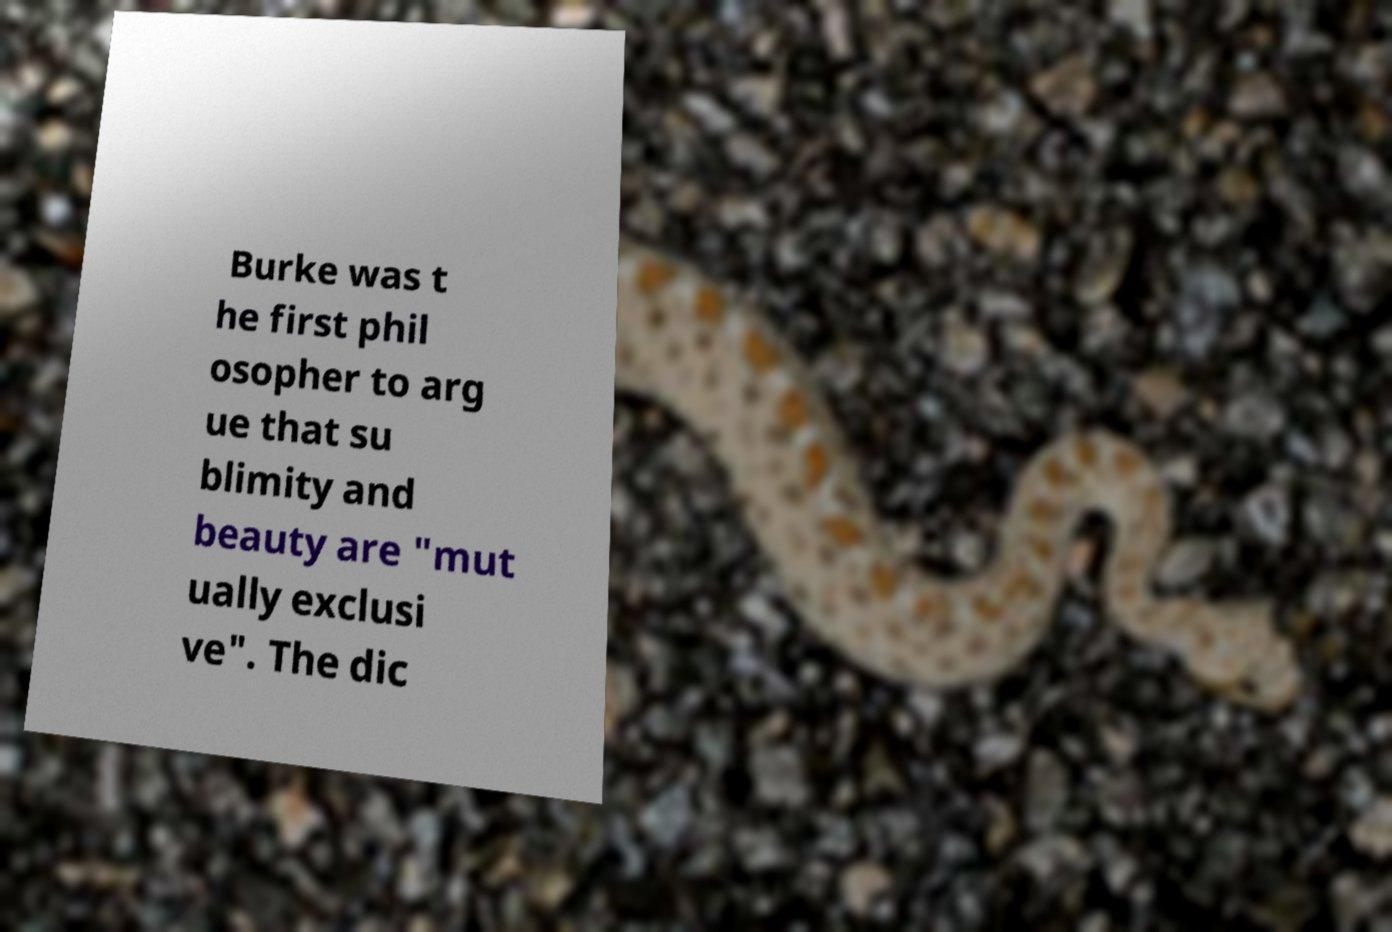Please read and relay the text visible in this image. What does it say? Burke was t he first phil osopher to arg ue that su blimity and beauty are "mut ually exclusi ve". The dic 